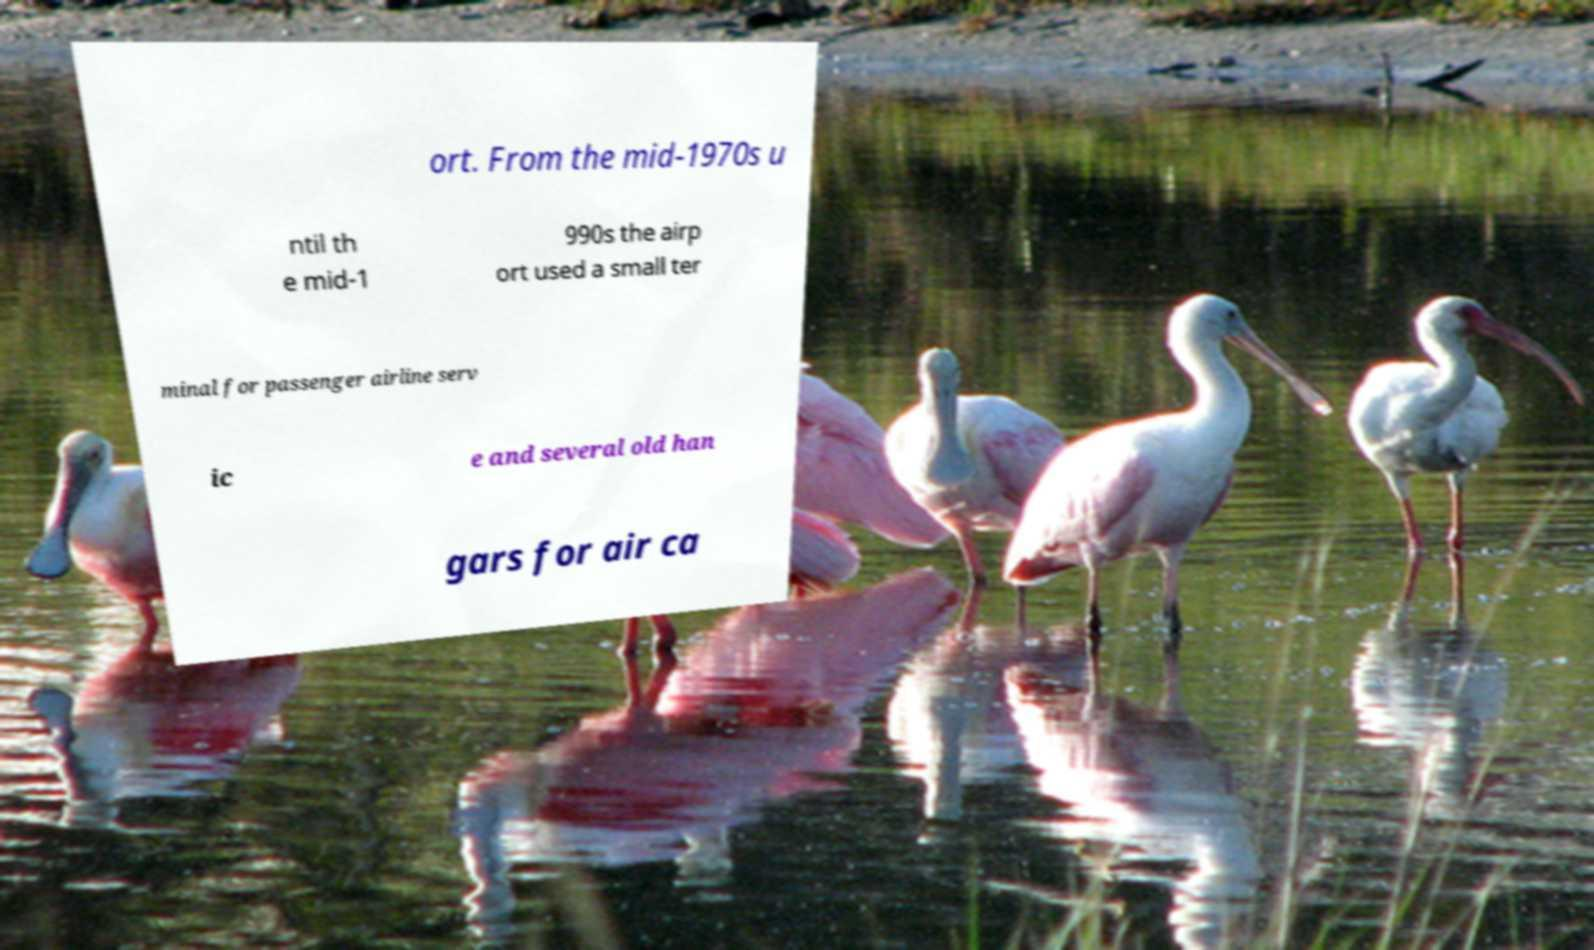I need the written content from this picture converted into text. Can you do that? ort. From the mid-1970s u ntil th e mid-1 990s the airp ort used a small ter minal for passenger airline serv ic e and several old han gars for air ca 